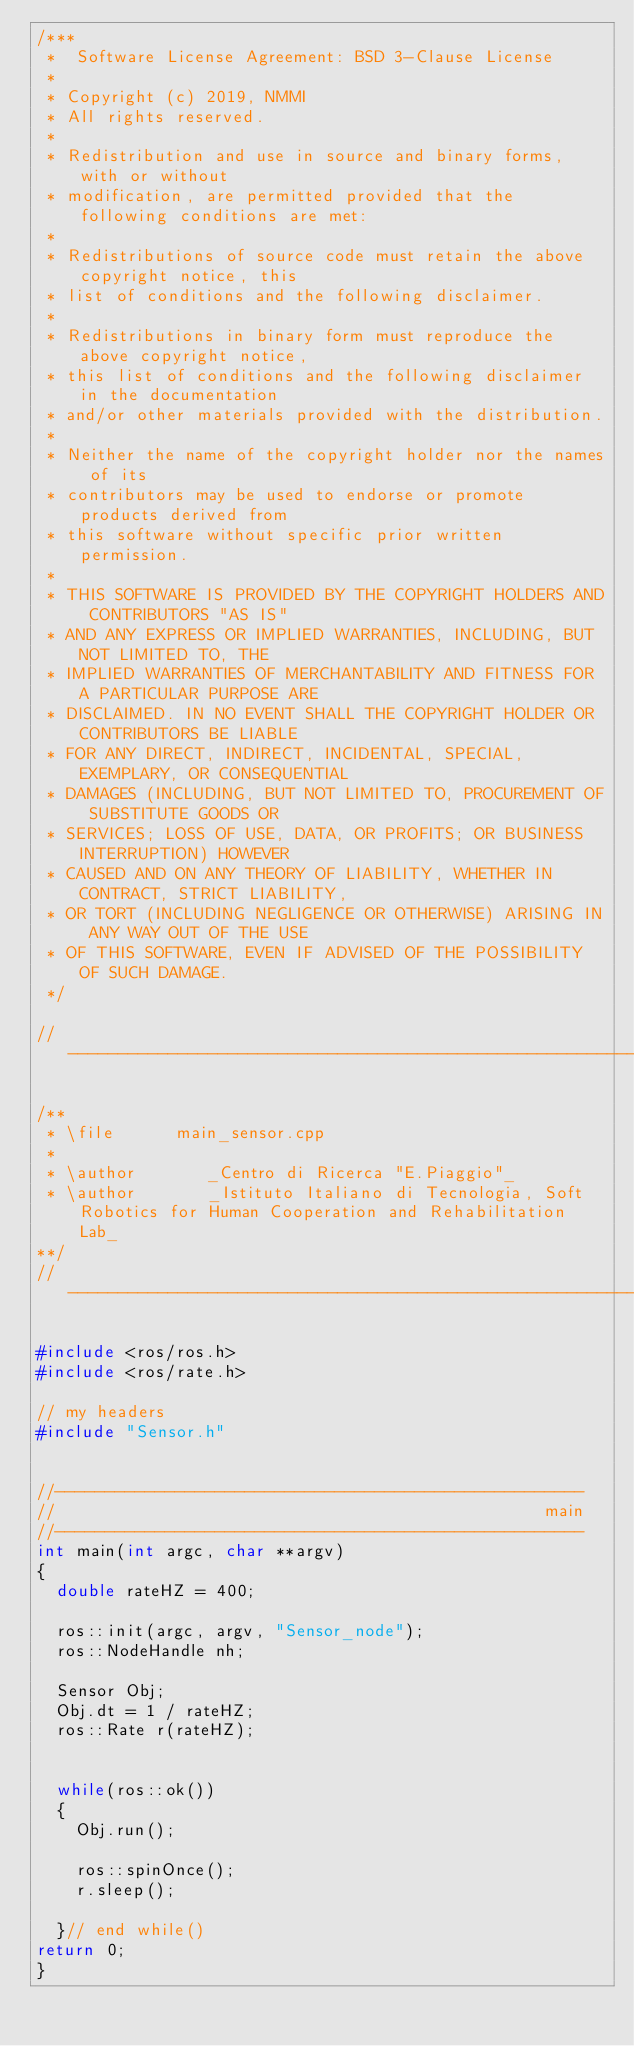<code> <loc_0><loc_0><loc_500><loc_500><_C++_>/***
 *  Software License Agreement: BSD 3-Clause License
 *
 * Copyright (c) 2019, NMMI
 * All rights reserved.
 *
 * Redistribution and use in source and binary forms, with or without
 * modification, are permitted provided that the following conditions are met:
 *
 * Redistributions of source code must retain the above copyright notice, this
 * list of conditions and the following disclaimer.
 *
 * Redistributions in binary form must reproduce the above copyright notice,
 * this list of conditions and the following disclaimer in the documentation
 * and/or other materials provided with the distribution.
 *
 * Neither the name of the copyright holder nor the names of its
 * contributors may be used to endorse or promote products derived from
 * this software without specific prior written permission.
 *
 * THIS SOFTWARE IS PROVIDED BY THE COPYRIGHT HOLDERS AND CONTRIBUTORS "AS IS"
 * AND ANY EXPRESS OR IMPLIED WARRANTIES, INCLUDING, BUT NOT LIMITED TO, THE
 * IMPLIED WARRANTIES OF MERCHANTABILITY AND FITNESS FOR A PARTICULAR PURPOSE ARE
 * DISCLAIMED. IN NO EVENT SHALL THE COPYRIGHT HOLDER OR CONTRIBUTORS BE LIABLE
 * FOR ANY DIRECT, INDIRECT, INCIDENTAL, SPECIAL, EXEMPLARY, OR CONSEQUENTIAL
 * DAMAGES (INCLUDING, BUT NOT LIMITED TO, PROCUREMENT OF SUBSTITUTE GOODS OR
 * SERVICES; LOSS OF USE, DATA, OR PROFITS; OR BUSINESS INTERRUPTION) HOWEVER
 * CAUSED AND ON ANY THEORY OF LIABILITY, WHETHER IN CONTRACT, STRICT LIABILITY,
 * OR TORT (INCLUDING NEGLIGENCE OR OTHERWISE) ARISING IN ANY WAY OUT OF THE USE
 * OF THIS SOFTWARE, EVEN IF ADVISED OF THE POSSIBILITY OF SUCH DAMAGE.
 */

// ----------------------------------------------------------------------------

/**
 * \file      main_sensor.cpp
 *
 * \author       _Centro di Ricerca "E.Piaggio"_
 * \author       _Istituto Italiano di Tecnologia, Soft Robotics for Human Cooperation and Rehabilitation Lab_
**/
// ----------------------------------------------------------------------------

#include <ros/ros.h>
#include <ros/rate.h>

// my headers
#include "Sensor.h"


//-----------------------------------------------------
//                                                 main
//-----------------------------------------------------
int main(int argc, char **argv)
{
  double rateHZ = 400;

  ros::init(argc, argv, "Sensor_node");
  ros::NodeHandle nh;

  Sensor Obj;
  Obj.dt = 1 / rateHZ;
  ros::Rate r(rateHZ);


  while(ros::ok())
  {
    Obj.run();

    ros::spinOnce();
    r.sleep();
        
  }// end while()
return 0;
}</code> 